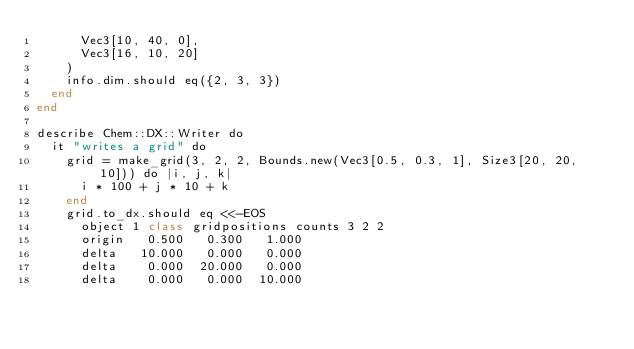<code> <loc_0><loc_0><loc_500><loc_500><_Crystal_>      Vec3[10, 40, 0],
      Vec3[16, 10, 20]
    )
    info.dim.should eq({2, 3, 3})
  end
end

describe Chem::DX::Writer do
  it "writes a grid" do
    grid = make_grid(3, 2, 2, Bounds.new(Vec3[0.5, 0.3, 1], Size3[20, 20, 10])) do |i, j, k|
      i * 100 + j * 10 + k
    end
    grid.to_dx.should eq <<-EOS
      object 1 class gridpositions counts 3 2 2
      origin   0.500   0.300   1.000
      delta   10.000   0.000   0.000
      delta    0.000  20.000   0.000
      delta    0.000   0.000  10.000</code> 